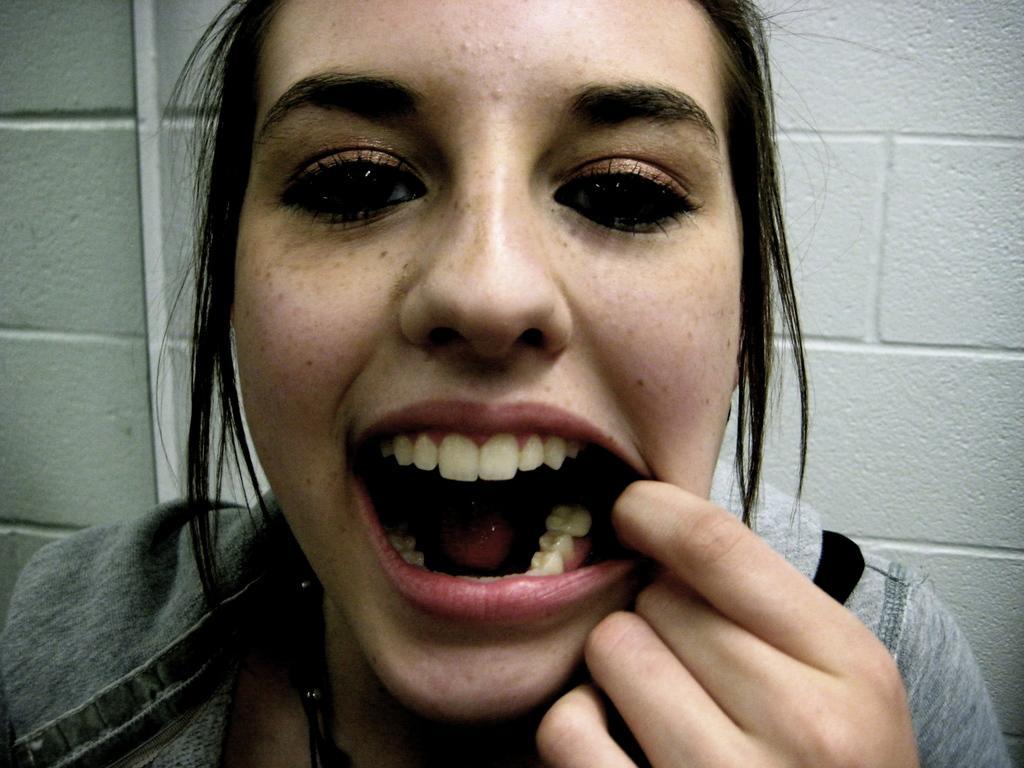Can you describe this image briefly? There is a lady wearing some black threads with pearls on the neck. In the back there's a wall. 